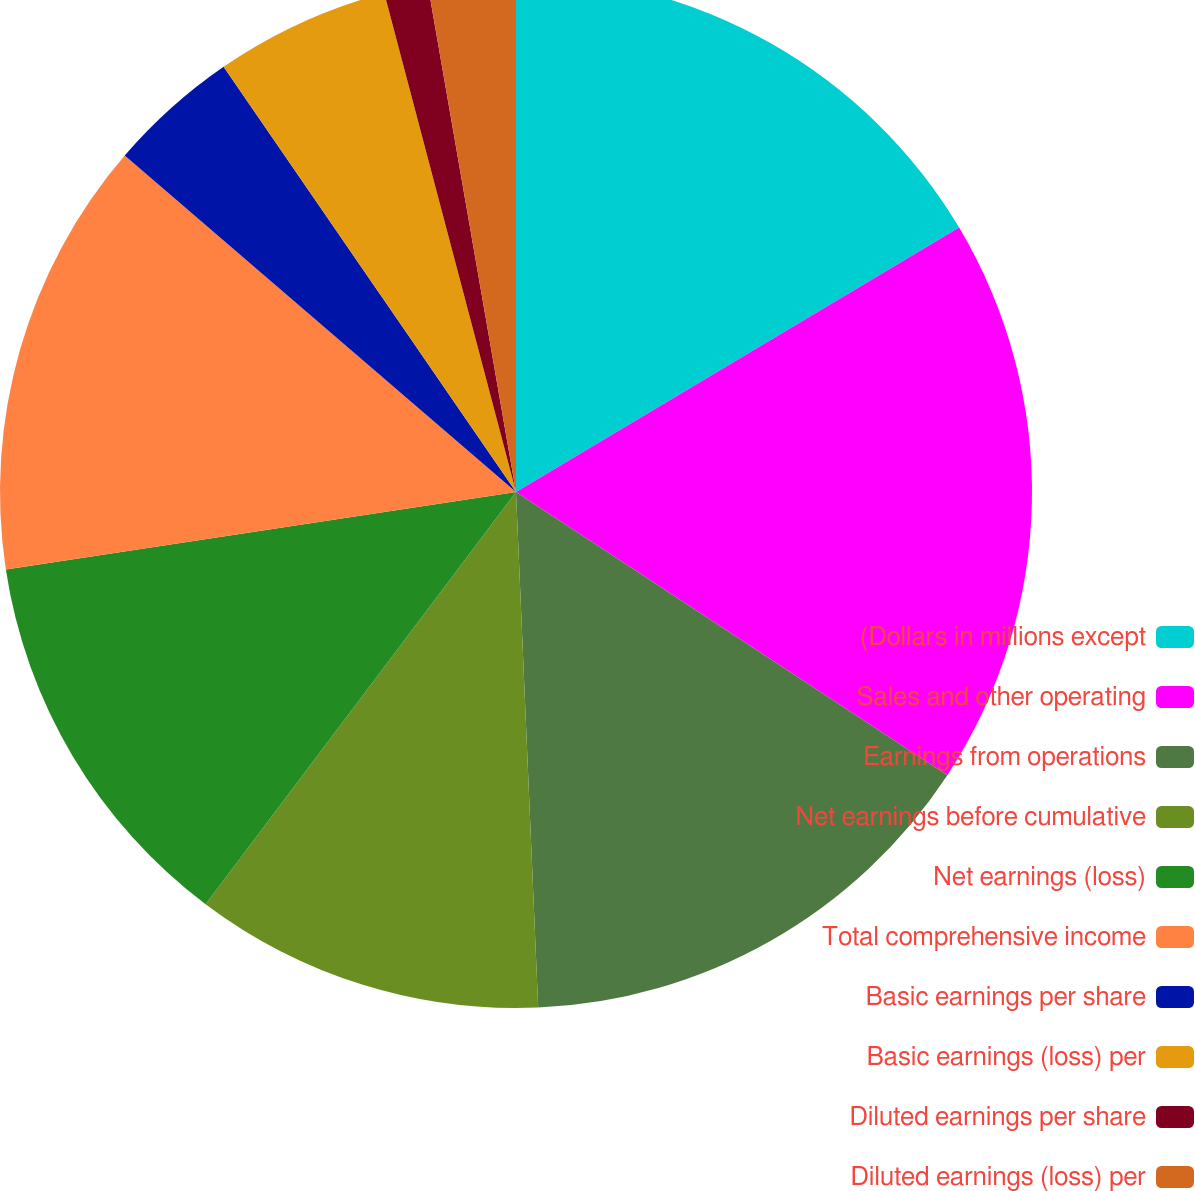Convert chart. <chart><loc_0><loc_0><loc_500><loc_500><pie_chart><fcel>(Dollars in millions except<fcel>Sales and other operating<fcel>Earnings from operations<fcel>Net earnings before cumulative<fcel>Net earnings (loss)<fcel>Total comprehensive income<fcel>Basic earnings per share<fcel>Basic earnings (loss) per<fcel>Diluted earnings per share<fcel>Diluted earnings (loss) per<nl><fcel>16.44%<fcel>17.81%<fcel>15.07%<fcel>10.96%<fcel>12.33%<fcel>13.7%<fcel>4.11%<fcel>5.48%<fcel>1.37%<fcel>2.74%<nl></chart> 